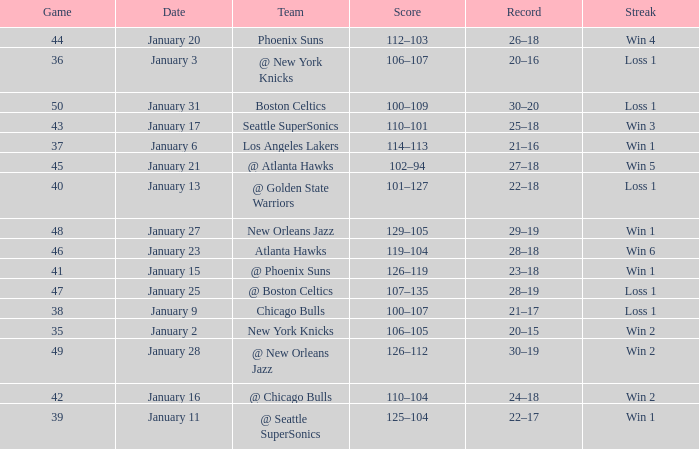What is the Team in Game 41? @ Phoenix Suns. 